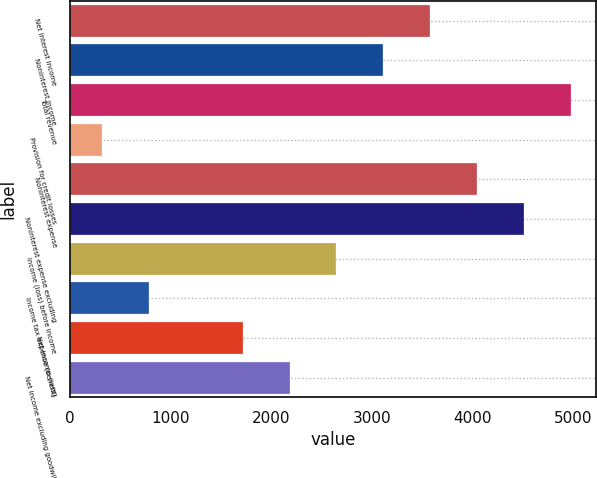Convert chart. <chart><loc_0><loc_0><loc_500><loc_500><bar_chart><fcel>Net interest income<fcel>Noninterest income<fcel>Total revenue<fcel>Provision for credit losses<fcel>Noninterest expense<fcel>Noninterest expense excluding<fcel>Income (loss) before income<fcel>Income tax expense (benefit)<fcel>Net income (loss)<fcel>Net income excluding goodwill<nl><fcel>3581<fcel>3115<fcel>4979<fcel>319<fcel>4047<fcel>4513<fcel>2649<fcel>785<fcel>1717<fcel>2183<nl></chart> 